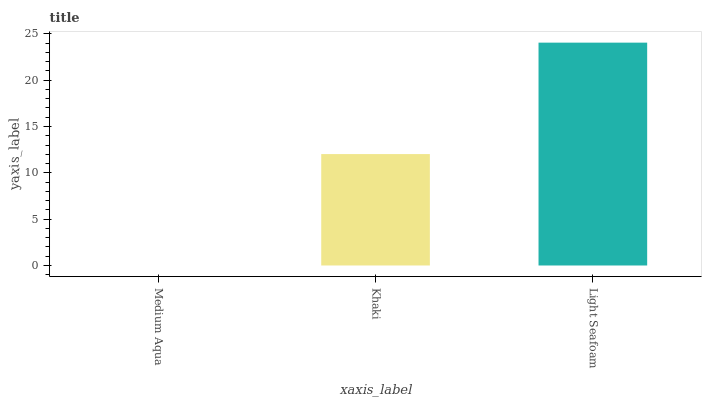Is Khaki the minimum?
Answer yes or no. No. Is Khaki the maximum?
Answer yes or no. No. Is Khaki greater than Medium Aqua?
Answer yes or no. Yes. Is Medium Aqua less than Khaki?
Answer yes or no. Yes. Is Medium Aqua greater than Khaki?
Answer yes or no. No. Is Khaki less than Medium Aqua?
Answer yes or no. No. Is Khaki the high median?
Answer yes or no. Yes. Is Khaki the low median?
Answer yes or no. Yes. Is Light Seafoam the high median?
Answer yes or no. No. Is Light Seafoam the low median?
Answer yes or no. No. 